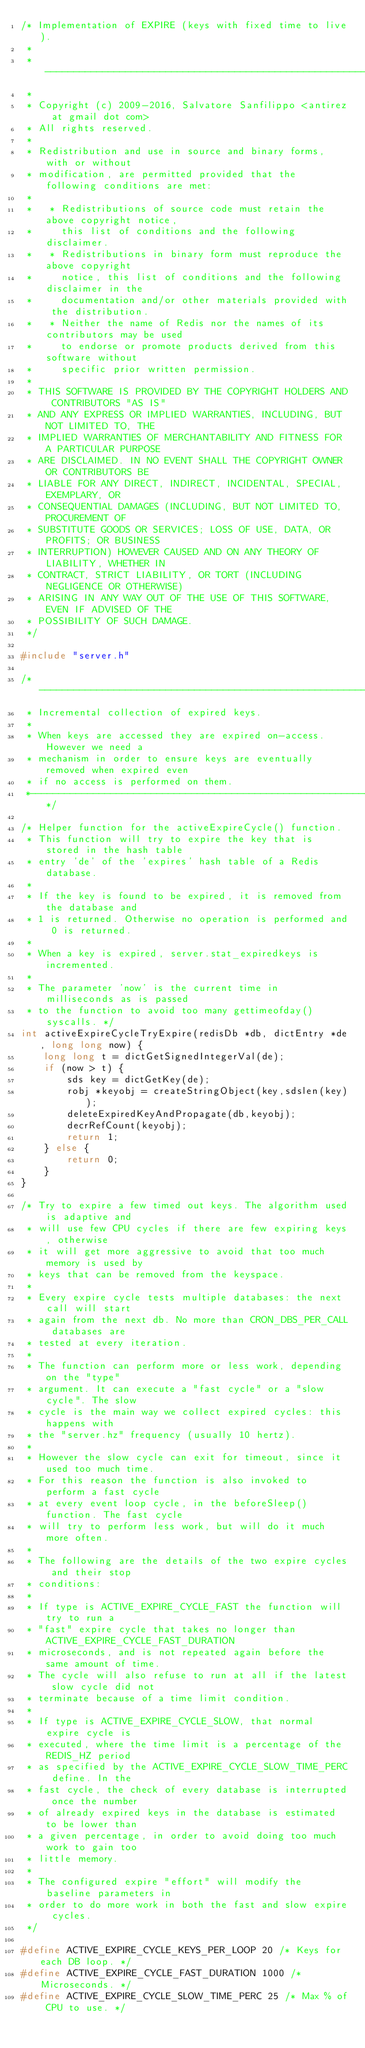<code> <loc_0><loc_0><loc_500><loc_500><_C_>/* Implementation of EXPIRE (keys with fixed time to live).
 *
 * ----------------------------------------------------------------------------
 *
 * Copyright (c) 2009-2016, Salvatore Sanfilippo <antirez at gmail dot com>
 * All rights reserved.
 *
 * Redistribution and use in source and binary forms, with or without
 * modification, are permitted provided that the following conditions are met:
 *
 *   * Redistributions of source code must retain the above copyright notice,
 *     this list of conditions and the following disclaimer.
 *   * Redistributions in binary form must reproduce the above copyright
 *     notice, this list of conditions and the following disclaimer in the
 *     documentation and/or other materials provided with the distribution.
 *   * Neither the name of Redis nor the names of its contributors may be used
 *     to endorse or promote products derived from this software without
 *     specific prior written permission.
 *
 * THIS SOFTWARE IS PROVIDED BY THE COPYRIGHT HOLDERS AND CONTRIBUTORS "AS IS"
 * AND ANY EXPRESS OR IMPLIED WARRANTIES, INCLUDING, BUT NOT LIMITED TO, THE
 * IMPLIED WARRANTIES OF MERCHANTABILITY AND FITNESS FOR A PARTICULAR PURPOSE
 * ARE DISCLAIMED. IN NO EVENT SHALL THE COPYRIGHT OWNER OR CONTRIBUTORS BE
 * LIABLE FOR ANY DIRECT, INDIRECT, INCIDENTAL, SPECIAL, EXEMPLARY, OR
 * CONSEQUENTIAL DAMAGES (INCLUDING, BUT NOT LIMITED TO, PROCUREMENT OF
 * SUBSTITUTE GOODS OR SERVICES; LOSS OF USE, DATA, OR PROFITS; OR BUSINESS
 * INTERRUPTION) HOWEVER CAUSED AND ON ANY THEORY OF LIABILITY, WHETHER IN
 * CONTRACT, STRICT LIABILITY, OR TORT (INCLUDING NEGLIGENCE OR OTHERWISE)
 * ARISING IN ANY WAY OUT OF THE USE OF THIS SOFTWARE, EVEN IF ADVISED OF THE
 * POSSIBILITY OF SUCH DAMAGE.
 */

#include "server.h"

/*-----------------------------------------------------------------------------
 * Incremental collection of expired keys.
 *
 * When keys are accessed they are expired on-access. However we need a
 * mechanism in order to ensure keys are eventually removed when expired even
 * if no access is performed on them.
 *----------------------------------------------------------------------------*/

/* Helper function for the activeExpireCycle() function.
 * This function will try to expire the key that is stored in the hash table
 * entry 'de' of the 'expires' hash table of a Redis database.
 *
 * If the key is found to be expired, it is removed from the database and
 * 1 is returned. Otherwise no operation is performed and 0 is returned.
 *
 * When a key is expired, server.stat_expiredkeys is incremented.
 *
 * The parameter 'now' is the current time in milliseconds as is passed
 * to the function to avoid too many gettimeofday() syscalls. */
int activeExpireCycleTryExpire(redisDb *db, dictEntry *de, long long now) {
    long long t = dictGetSignedIntegerVal(de);
    if (now > t) {
        sds key = dictGetKey(de);
        robj *keyobj = createStringObject(key,sdslen(key));
        deleteExpiredKeyAndPropagate(db,keyobj);
        decrRefCount(keyobj);
        return 1;
    } else {
        return 0;
    }
}

/* Try to expire a few timed out keys. The algorithm used is adaptive and
 * will use few CPU cycles if there are few expiring keys, otherwise
 * it will get more aggressive to avoid that too much memory is used by
 * keys that can be removed from the keyspace.
 *
 * Every expire cycle tests multiple databases: the next call will start
 * again from the next db. No more than CRON_DBS_PER_CALL databases are
 * tested at every iteration.
 *
 * The function can perform more or less work, depending on the "type"
 * argument. It can execute a "fast cycle" or a "slow cycle". The slow
 * cycle is the main way we collect expired cycles: this happens with
 * the "server.hz" frequency (usually 10 hertz).
 *
 * However the slow cycle can exit for timeout, since it used too much time.
 * For this reason the function is also invoked to perform a fast cycle
 * at every event loop cycle, in the beforeSleep() function. The fast cycle
 * will try to perform less work, but will do it much more often.
 *
 * The following are the details of the two expire cycles and their stop
 * conditions:
 *
 * If type is ACTIVE_EXPIRE_CYCLE_FAST the function will try to run a
 * "fast" expire cycle that takes no longer than ACTIVE_EXPIRE_CYCLE_FAST_DURATION
 * microseconds, and is not repeated again before the same amount of time.
 * The cycle will also refuse to run at all if the latest slow cycle did not
 * terminate because of a time limit condition.
 *
 * If type is ACTIVE_EXPIRE_CYCLE_SLOW, that normal expire cycle is
 * executed, where the time limit is a percentage of the REDIS_HZ period
 * as specified by the ACTIVE_EXPIRE_CYCLE_SLOW_TIME_PERC define. In the
 * fast cycle, the check of every database is interrupted once the number
 * of already expired keys in the database is estimated to be lower than
 * a given percentage, in order to avoid doing too much work to gain too
 * little memory.
 *
 * The configured expire "effort" will modify the baseline parameters in
 * order to do more work in both the fast and slow expire cycles.
 */

#define ACTIVE_EXPIRE_CYCLE_KEYS_PER_LOOP 20 /* Keys for each DB loop. */
#define ACTIVE_EXPIRE_CYCLE_FAST_DURATION 1000 /* Microseconds. */
#define ACTIVE_EXPIRE_CYCLE_SLOW_TIME_PERC 25 /* Max % of CPU to use. */</code> 